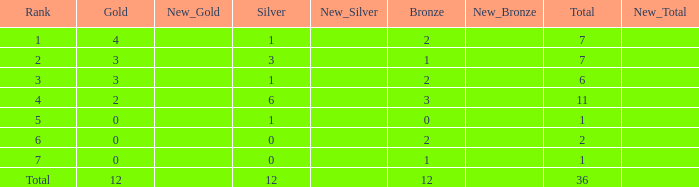What is the largest total for a team with fewer than 12 bronze, 1 silver and 0 gold medals? 1.0. 